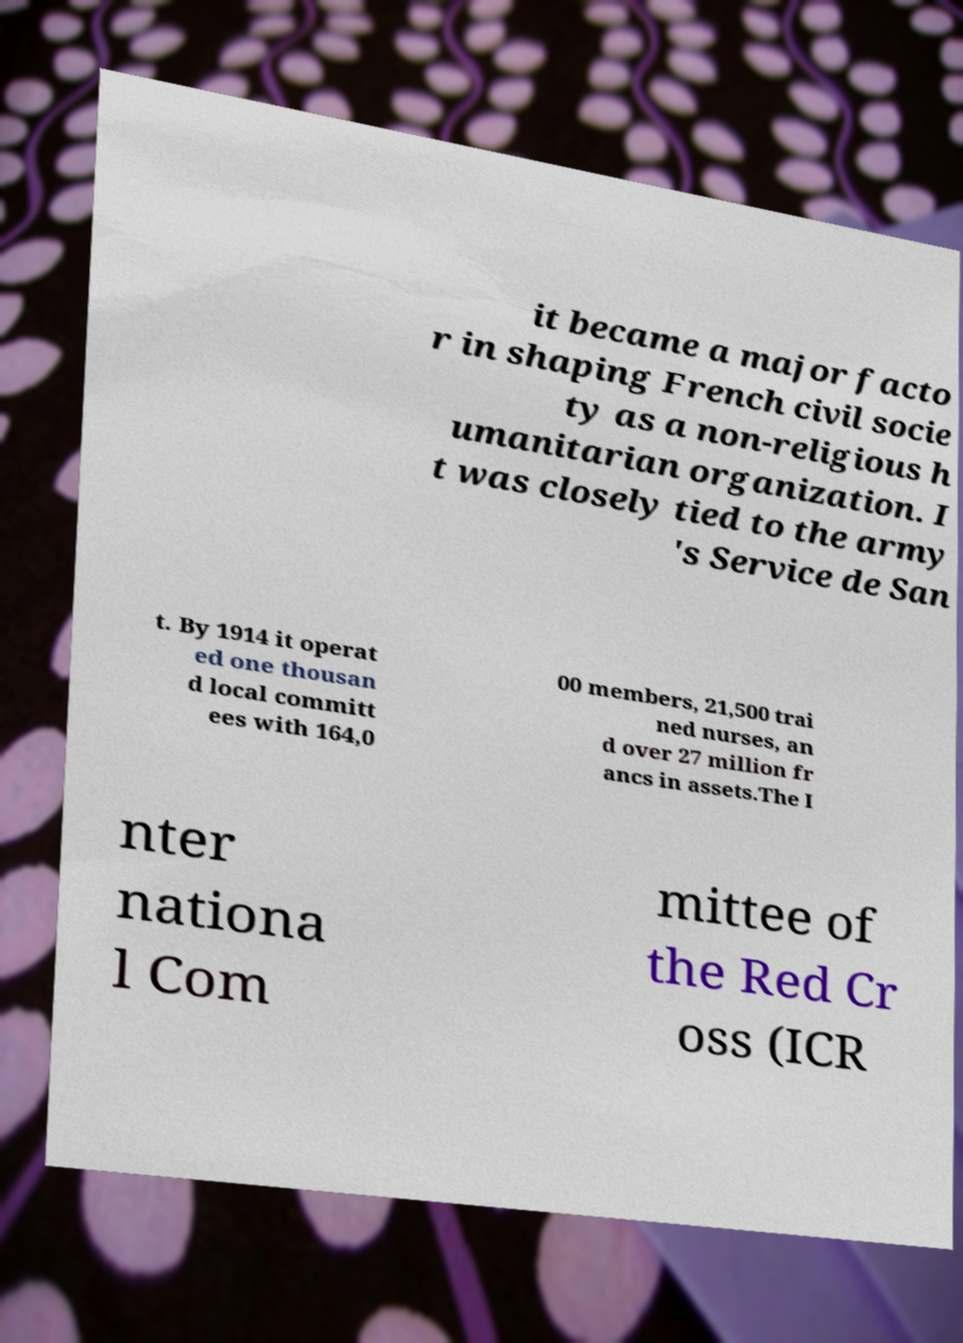Can you accurately transcribe the text from the provided image for me? it became a major facto r in shaping French civil socie ty as a non-religious h umanitarian organization. I t was closely tied to the army 's Service de San t. By 1914 it operat ed one thousan d local committ ees with 164,0 00 members, 21,500 trai ned nurses, an d over 27 million fr ancs in assets.The I nter nationa l Com mittee of the Red Cr oss (ICR 